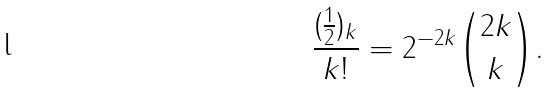Convert formula to latex. <formula><loc_0><loc_0><loc_500><loc_500>\frac { ( \frac { 1 } { 2 } ) _ { k } } { k ! } = 2 ^ { - 2 k } \binom { 2 k } k .</formula> 